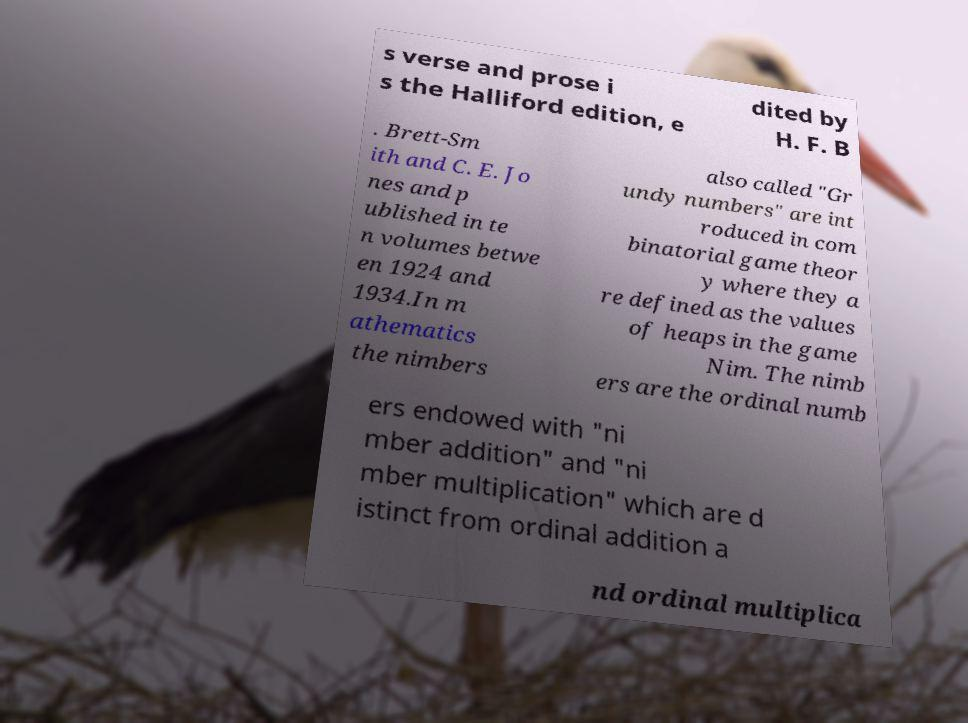Could you assist in decoding the text presented in this image and type it out clearly? s verse and prose i s the Halliford edition, e dited by H. F. B . Brett-Sm ith and C. E. Jo nes and p ublished in te n volumes betwe en 1924 and 1934.In m athematics the nimbers also called "Gr undy numbers" are int roduced in com binatorial game theor y where they a re defined as the values of heaps in the game Nim. The nimb ers are the ordinal numb ers endowed with "ni mber addition" and "ni mber multiplication" which are d istinct from ordinal addition a nd ordinal multiplica 